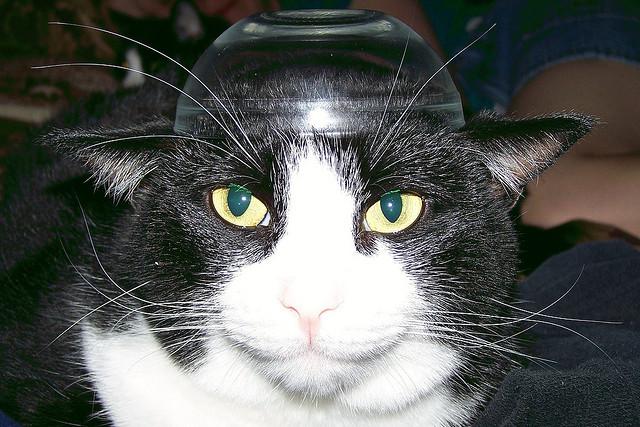How amused does this cat look at wearing a bowl on its head?
Short answer required. Not amused. Should this bowl be on the cat's head?
Write a very short answer. No. Is this cat wearing an ugly hat?
Be succinct. No. 